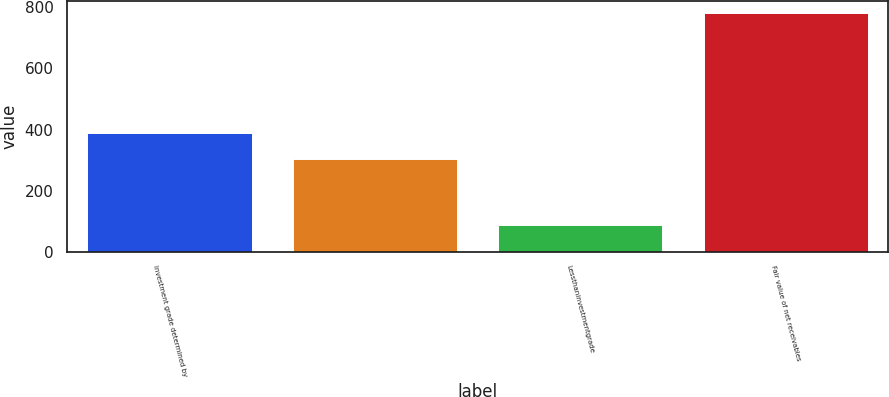Convert chart. <chart><loc_0><loc_0><loc_500><loc_500><bar_chart><fcel>Investment grade determined by<fcel>Unnamed: 1<fcel>Lessthaninvestmentgrade<fcel>Fair value of net receivables<nl><fcel>389<fcel>304<fcel>89<fcel>782<nl></chart> 